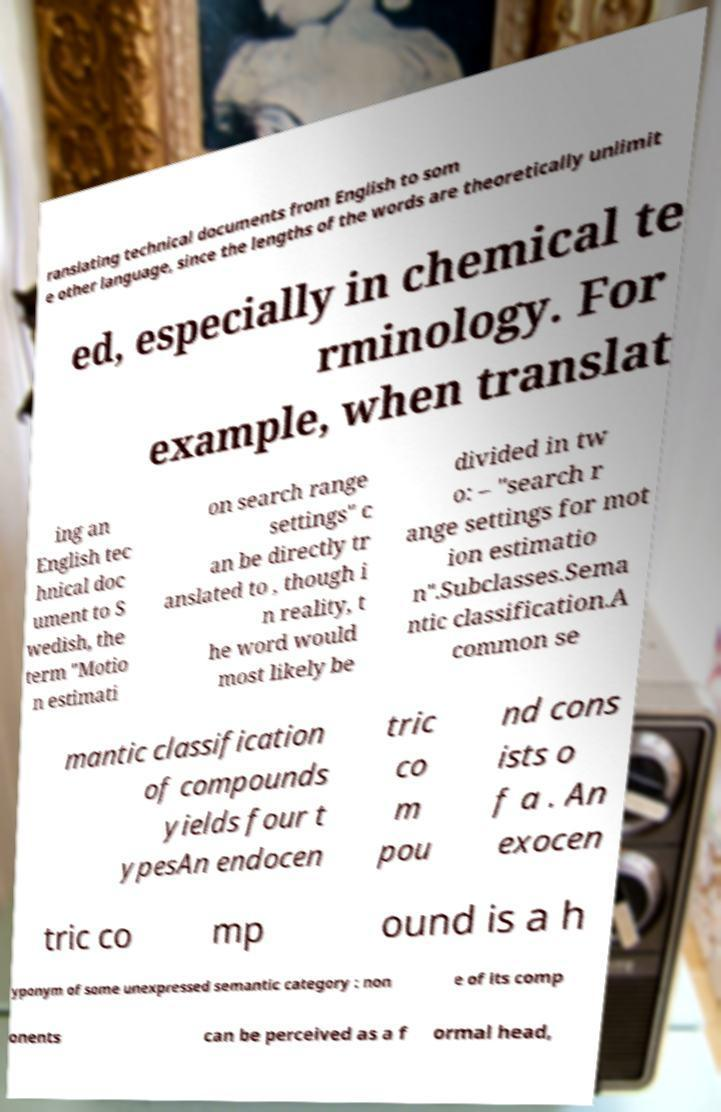Can you accurately transcribe the text from the provided image for me? ranslating technical documents from English to som e other language, since the lengths of the words are theoretically unlimit ed, especially in chemical te rminology. For example, when translat ing an English tec hnical doc ument to S wedish, the term "Motio n estimati on search range settings" c an be directly tr anslated to , though i n reality, t he word would most likely be divided in tw o: – "search r ange settings for mot ion estimatio n".Subclasses.Sema ntic classification.A common se mantic classification of compounds yields four t ypesAn endocen tric co m pou nd cons ists o f a . An exocen tric co mp ound is a h yponym of some unexpressed semantic category : non e of its comp onents can be perceived as a f ormal head, 